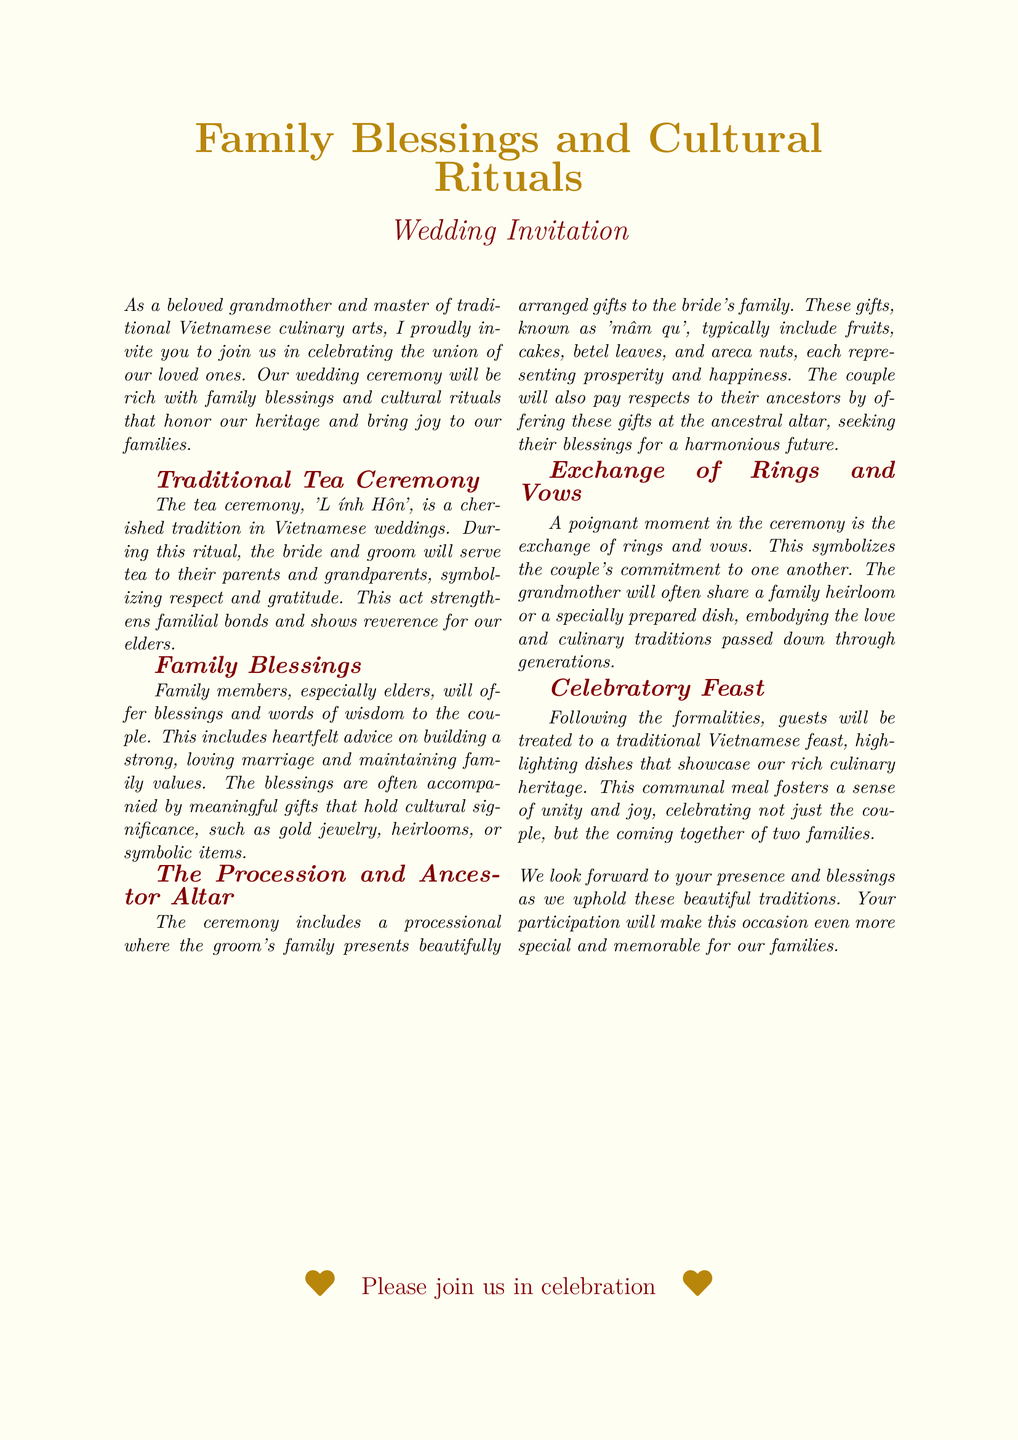What is the title of the event? The title of the event is prominently mentioned in the document as "Family Blessings and Cultural Rituals."
Answer: Family Blessings and Cultural Rituals What is the name of the traditional ceremony mentioned? The document refers to the traditional ceremony as 'Lễ Đính Hôn.'
Answer: Lễ Đính Hôn What do the gifts presented in the procession symbolize? The gifts presented are interpreted in the document as representing prosperity and happiness.
Answer: Prosperity and happiness What does the grandmother often share during the exchange of rings and vows? It mentions that the grandmother will share a family heirloom or a specially prepared dish.
Answer: Family heirloom or a specially prepared dish What type of meal is served following the formalities? The document specifies that a traditional Vietnamese feast is served after the formalities.
Answer: Traditional Vietnamese feast Who offers blessings to the couple during the ceremony? The blessings are offered primarily by family members, especially elders.
Answer: Family members, especially elders What will guests experience at the celebration? The guests will experience unity and joy as highlighted in the document.
Answer: Unity and joy What significance do the gifts hold during the 'mâm quả'? In the document, the gifts hold cultural significance with elements like fruits, cakes, and betel leaves.
Answer: Cultural significance What emotion is the invitation expressing? The invitation conveys a sense of joy and celebration for the event.
Answer: Joy and celebration 